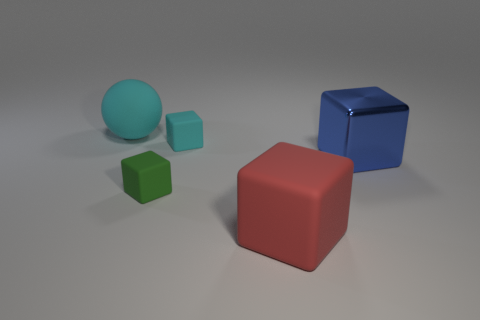There is a small thing that is in front of the blue metal thing; what number of cyan rubber things are on the left side of it?
Offer a very short reply. 1. Is there any other thing that has the same material as the blue block?
Keep it short and to the point. No. There is a large cube that is behind the small rubber cube that is in front of the big blue thing that is in front of the cyan ball; what is its material?
Your answer should be compact. Metal. There is a big thing that is both right of the cyan block and behind the large red rubber cube; what material is it?
Provide a succinct answer. Metal. What number of tiny rubber objects are the same shape as the blue metallic object?
Provide a short and direct response. 2. There is a cyan rubber thing that is in front of the matte object behind the small cyan matte block; what size is it?
Your response must be concise. Small. There is a big rubber thing behind the blue metal object; does it have the same color as the tiny matte block on the right side of the green rubber object?
Your answer should be very brief. Yes. There is a small cube in front of the cyan thing on the right side of the large cyan object; what number of cubes are behind it?
Your response must be concise. 2. How many big things are both behind the tiny green object and in front of the blue metal block?
Keep it short and to the point. 0. Is the number of rubber objects in front of the blue block greater than the number of large rubber cylinders?
Keep it short and to the point. Yes. 